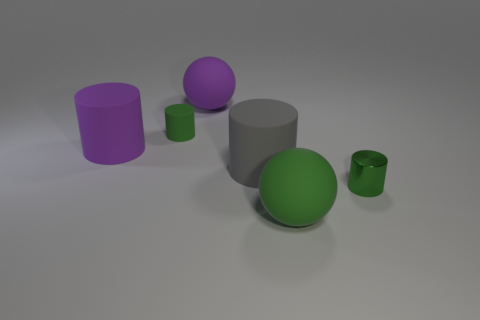Add 3 big rubber objects. How many objects exist? 9 Subtract all balls. How many objects are left? 4 Subtract all purple cylinders. Subtract all big red cylinders. How many objects are left? 5 Add 1 big rubber spheres. How many big rubber spheres are left? 3 Add 1 green metallic cylinders. How many green metallic cylinders exist? 2 Subtract 1 gray cylinders. How many objects are left? 5 